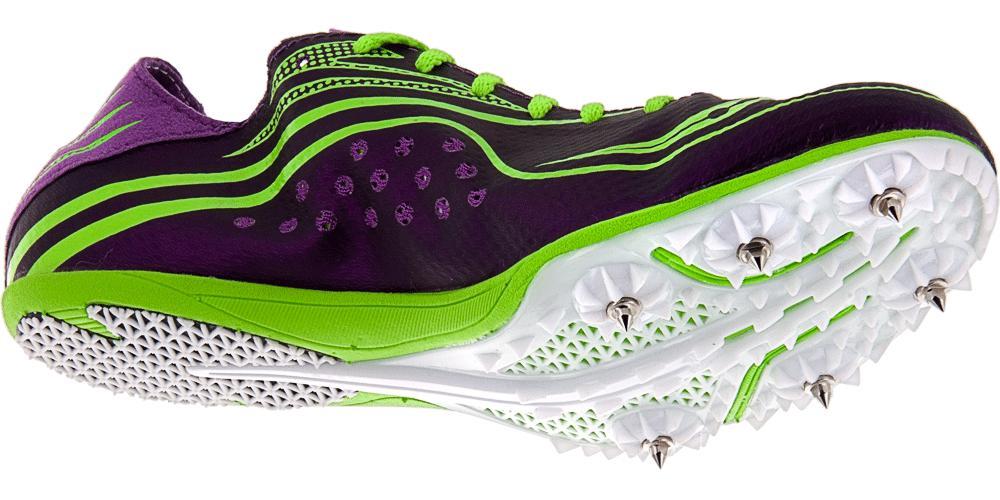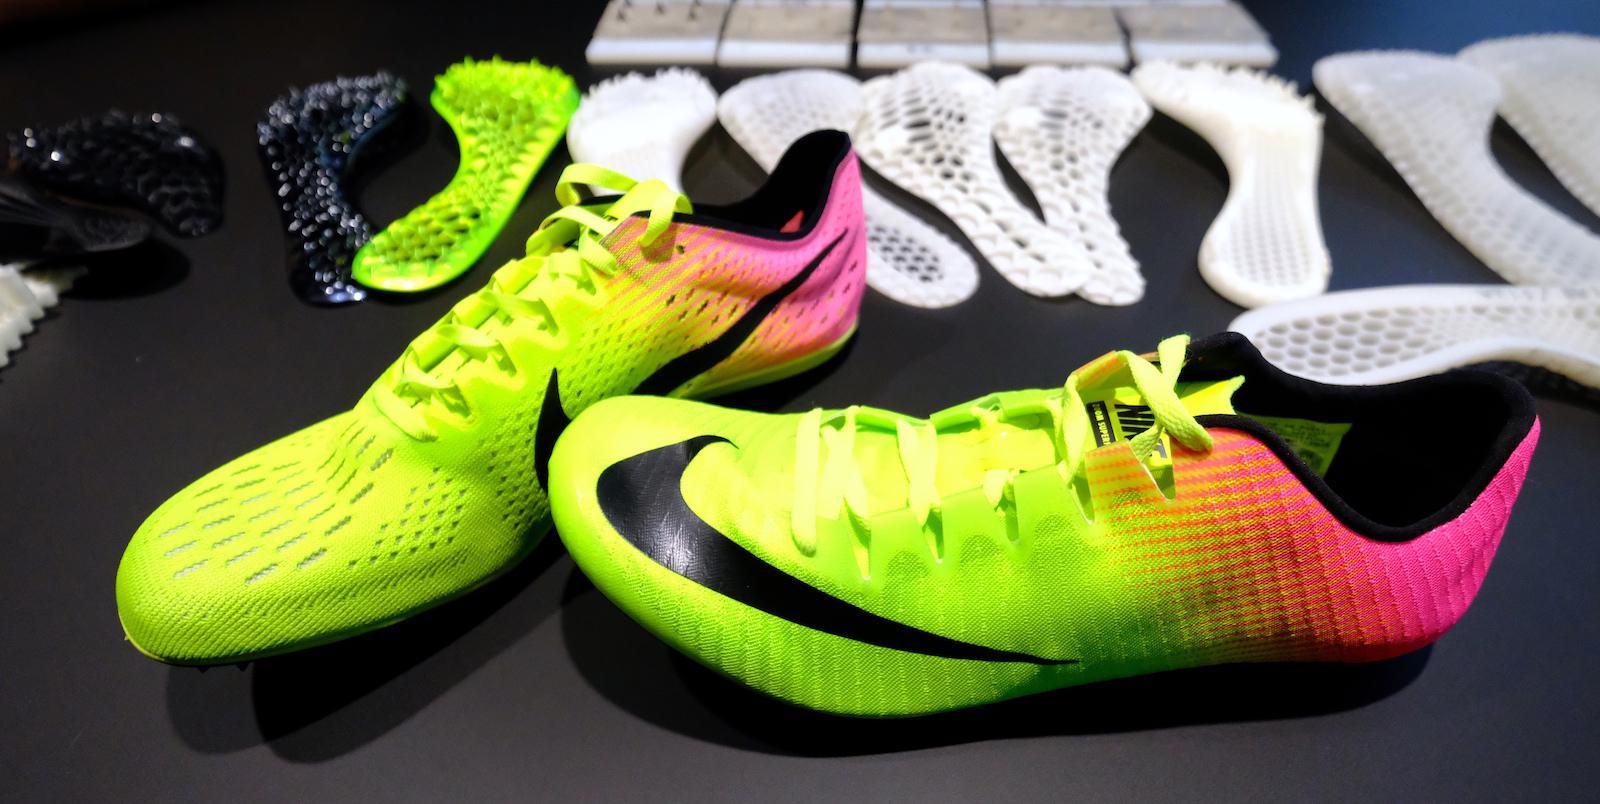The first image is the image on the left, the second image is the image on the right. Analyze the images presented: Is the assertion "There are many shoes in the image to the right." valid? Answer yes or no. No. The first image is the image on the left, the second image is the image on the right. Assess this claim about the two images: "There are at least 8 shoes.". Correct or not? Answer yes or no. No. 